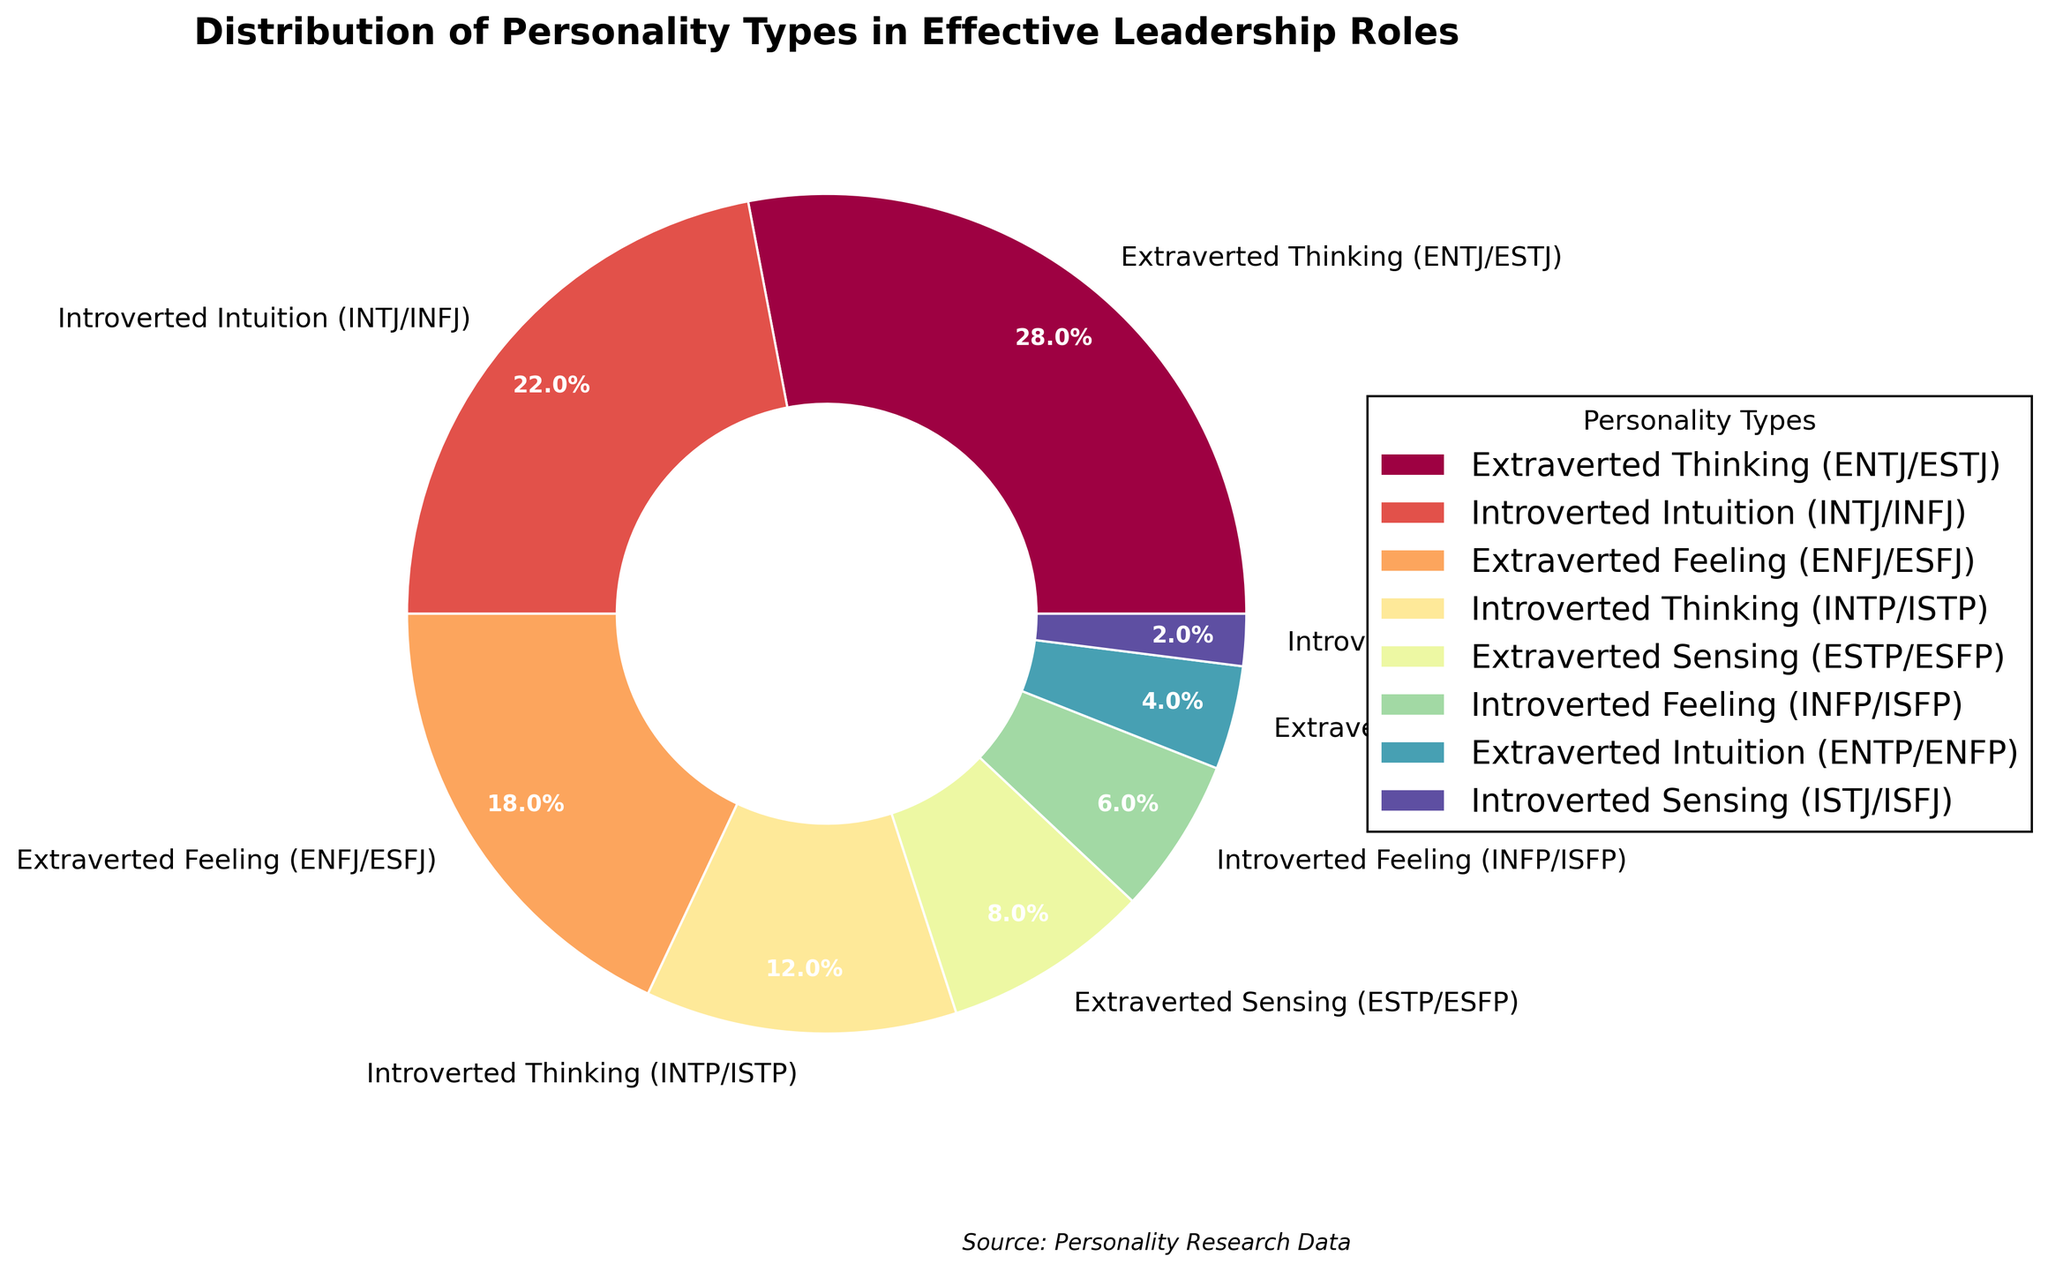What percentage of leadership roles is taken by Introverted personality types? Sum the percentages for all introverted personality types: Introverted Intuition (22%), Introverted Thinking (12%), Introverted Feeling (6%), and Introverted Sensing (2%). 22% + 12% + 6% + 2% = 42%
Answer: 42% Which personality type occupies the smallest portion of effective leadership roles? Review the percentages for all personality types and identify the smallest one, which is Introverted Sensing (ISTJ/ISFJ) at 2%.
Answer: Introverted Sensing (ISTJ/ISFJ) How much larger is the share of Extraverted Thinking (ENTJ/ESTJ) compared to Extraverted Intuition (ENTP/ENFP)? Calculate the difference between the percentages of Extraverted Thinking (28%) and Extraverted Intuition (4%). 28% - 4% = 24%
Answer: 24% Which two personality types together account for half of the leadership roles? Identify two personality types whose combined percentage is closest to 50%. Introverted Intuition (22%) and Extraverted Thinking (28%) together make 22% + 28% = 50%.
Answer: Introverted Intuition (INTJ/INFJ) and Extraverted Thinking (ENTJ/ESTJ) What is the ratio of Extraverted Feeling (ENFJ/ESFJ) to Introverted Thinking (INTP/ISTP)? Divide the percentage of Extraverted Feeling (18%) by Introverted Thinking (12%). 18/12 = 1.5
Answer: 1.5 If leadership roles were distributed equally among the personality types, what percentage would each type have? There are 8 personality types, so divide 100% by 8. 100% / 8 = 12.5%
Answer: 12.5% What is the cumulative percentage of leadership roles taken by Extraverted personality types? Sum the percentages for all extraverted personality types: Extraverted Thinking (28%), Extraverted Feeling (18%), Extraverted Sensing (8%), and Extraverted Intuition (4%). 28% + 18% + 8% + 4% = 58%
Answer: 58% Compare the combined percentage of Introverted Sensing (ISTJ/ISFJ) and Extraverted Sensing (ESTP/ESFP) to that of Introverted Thinking (INTP/ISTP). Which one is higher? Sum percentages for Introverted Sensing (2%) and Extraverted Sensing (8%) to get 10%. Compare it to Introverted Thinking's 12%. 12% is greater than 10%.
Answer: Introverted Thinking (INTP/ISTP) 